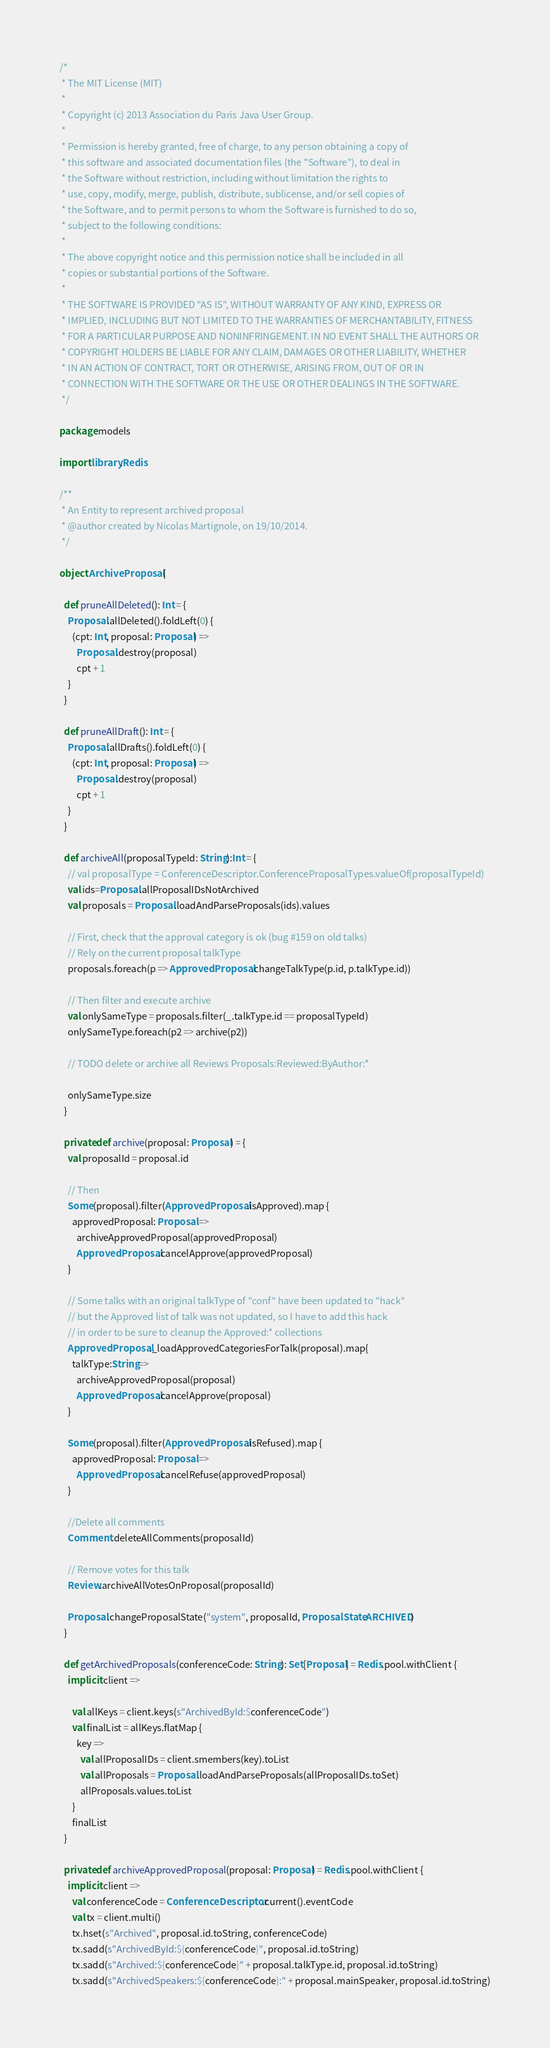Convert code to text. <code><loc_0><loc_0><loc_500><loc_500><_Scala_>/*
 * The MIT License (MIT)
 *
 * Copyright (c) 2013 Association du Paris Java User Group.
 *
 * Permission is hereby granted, free of charge, to any person obtaining a copy of
 * this software and associated documentation files (the "Software"), to deal in
 * the Software without restriction, including without limitation the rights to
 * use, copy, modify, merge, publish, distribute, sublicense, and/or sell copies of
 * the Software, and to permit persons to whom the Software is furnished to do so,
 * subject to the following conditions:
 *
 * The above copyright notice and this permission notice shall be included in all
 * copies or substantial portions of the Software.
 *
 * THE SOFTWARE IS PROVIDED "AS IS", WITHOUT WARRANTY OF ANY KIND, EXPRESS OR
 * IMPLIED, INCLUDING BUT NOT LIMITED TO THE WARRANTIES OF MERCHANTABILITY, FITNESS
 * FOR A PARTICULAR PURPOSE AND NONINFRINGEMENT. IN NO EVENT SHALL THE AUTHORS OR
 * COPYRIGHT HOLDERS BE LIABLE FOR ANY CLAIM, DAMAGES OR OTHER LIABILITY, WHETHER
 * IN AN ACTION OF CONTRACT, TORT OR OTHERWISE, ARISING FROM, OUT OF OR IN
 * CONNECTION WITH THE SOFTWARE OR THE USE OR OTHER DEALINGS IN THE SOFTWARE.
 */

package models

import library.Redis

/**
 * An Entity to represent archived proposal
 * @author created by Nicolas Martignole, on 19/10/2014.
 */

object ArchiveProposal {

  def pruneAllDeleted(): Int = {
    Proposal.allDeleted().foldLeft(0) {
      (cpt: Int, proposal: Proposal) =>
        Proposal.destroy(proposal)
        cpt + 1
    }
  }

  def pruneAllDraft(): Int = {
    Proposal.allDrafts().foldLeft(0) {
      (cpt: Int, proposal: Proposal) =>
        Proposal.destroy(proposal)
        cpt + 1
    }
  }

  def archiveAll(proposalTypeId: String):Int = {
    // val proposalType = ConferenceDescriptor.ConferenceProposalTypes.valueOf(proposalTypeId)
    val ids=Proposal.allProposalIDsNotArchived
    val proposals = Proposal.loadAndParseProposals(ids).values

    // First, check that the approval category is ok (bug #159 on old talks)
    // Rely on the current proposal talkType
    proposals.foreach(p => ApprovedProposal.changeTalkType(p.id, p.talkType.id))

    // Then filter and execute archive
    val onlySameType = proposals.filter(_.talkType.id == proposalTypeId)
    onlySameType.foreach(p2 => archive(p2))

    // TODO delete or archive all Reviews Proposals:Reviewed:ByAuthor:*

    onlySameType.size
  }

  private def archive(proposal: Proposal) = {
    val proposalId = proposal.id

    // Then
    Some(proposal).filter(ApprovedProposal.isApproved).map {
      approvedProposal: Proposal =>
        archiveApprovedProposal(approvedProposal)
        ApprovedProposal.cancelApprove(approvedProposal)
    }

    // Some talks with an original talkType of "conf" have been updated to "hack"
    // but the Approved list of talk was not updated, so I have to add this hack
    // in order to be sure to cleanup the Approved:* collections
    ApprovedProposal._loadApprovedCategoriesForTalk(proposal).map{
      talkType:String=>
        archiveApprovedProposal(proposal)
        ApprovedProposal.cancelApprove(proposal)
    }

    Some(proposal).filter(ApprovedProposal.isRefused).map {
      approvedProposal: Proposal =>
        ApprovedProposal.cancelRefuse(approvedProposal)
    }

    //Delete all comments
    Comment.deleteAllComments(proposalId)

    // Remove votes for this talk
    Review.archiveAllVotesOnProposal(proposalId)

    Proposal.changeProposalState("system", proposalId, ProposalState.ARCHIVED)
  }

  def getArchivedProposals(conferenceCode: String): Set[Proposal] = Redis.pool.withClient {
    implicit client =>

      val allKeys = client.keys(s"ArchivedById:$conferenceCode")
      val finalList = allKeys.flatMap {
        key =>
          val allProposalIDs = client.smembers(key).toList
          val allProposals = Proposal.loadAndParseProposals(allProposalIDs.toSet)
          allProposals.values.toList
      }
      finalList
  }

  private def archiveApprovedProposal(proposal: Proposal) = Redis.pool.withClient {
    implicit client =>
      val conferenceCode = ConferenceDescriptor.current().eventCode
      val tx = client.multi()
      tx.hset(s"Archived", proposal.id.toString, conferenceCode)
      tx.sadd(s"ArchivedById:${conferenceCode}", proposal.id.toString)
      tx.sadd(s"Archived:${conferenceCode}" + proposal.talkType.id, proposal.id.toString)
      tx.sadd(s"ArchivedSpeakers:${conferenceCode}:" + proposal.mainSpeaker, proposal.id.toString)</code> 